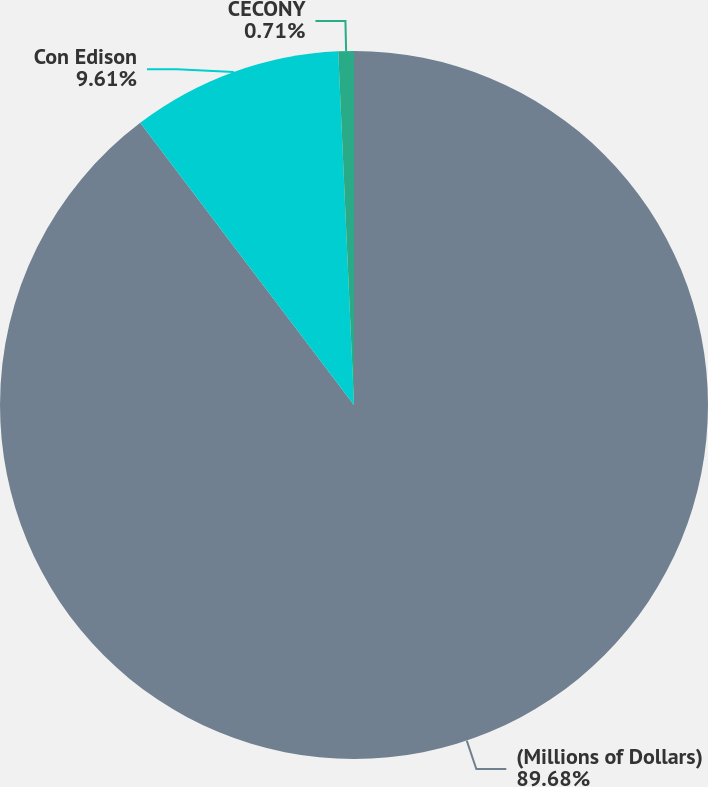Convert chart. <chart><loc_0><loc_0><loc_500><loc_500><pie_chart><fcel>(Millions of Dollars)<fcel>Con Edison<fcel>CECONY<nl><fcel>89.68%<fcel>9.61%<fcel>0.71%<nl></chart> 